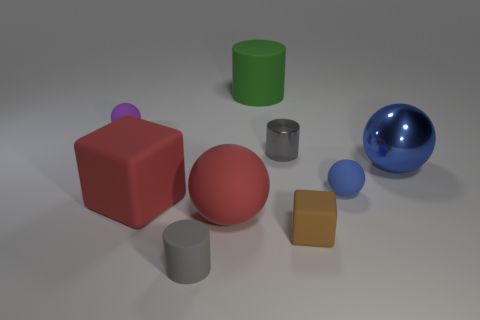Subtract all gray cylinders. How many were subtracted if there are1gray cylinders left? 1 Subtract all yellow balls. Subtract all purple cylinders. How many balls are left? 4 Subtract all spheres. How many objects are left? 5 Subtract all tiny brown things. Subtract all large rubber blocks. How many objects are left? 7 Add 5 big blue balls. How many big blue balls are left? 6 Add 6 big red matte balls. How many big red matte balls exist? 7 Subtract 2 gray cylinders. How many objects are left? 7 